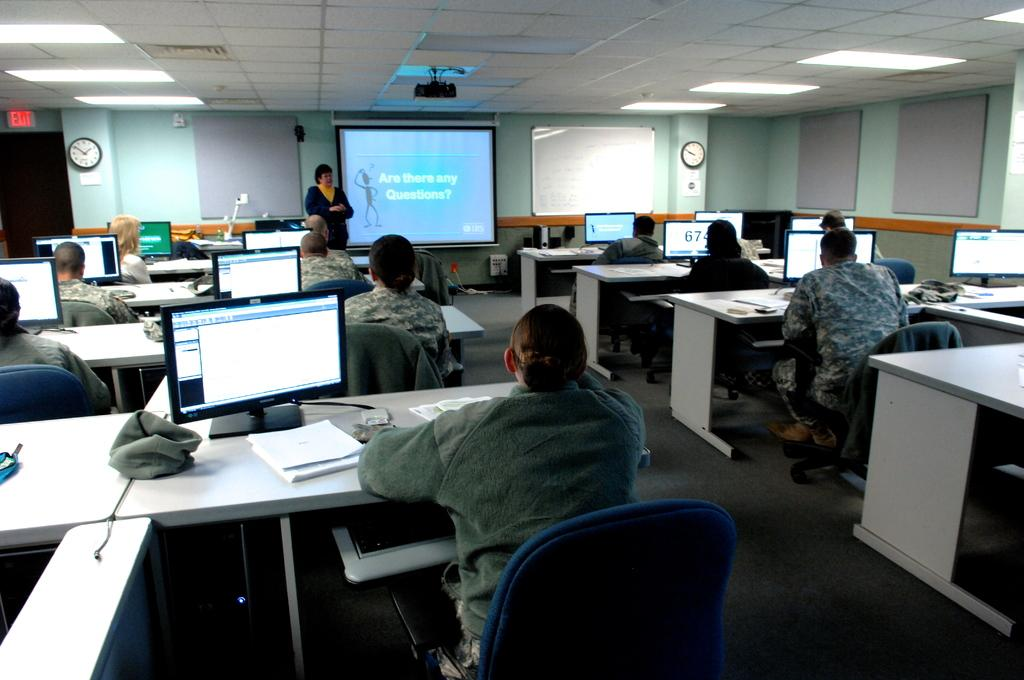<image>
Give a short and clear explanation of the subsequent image. The end of a power point asking if there are any questions 